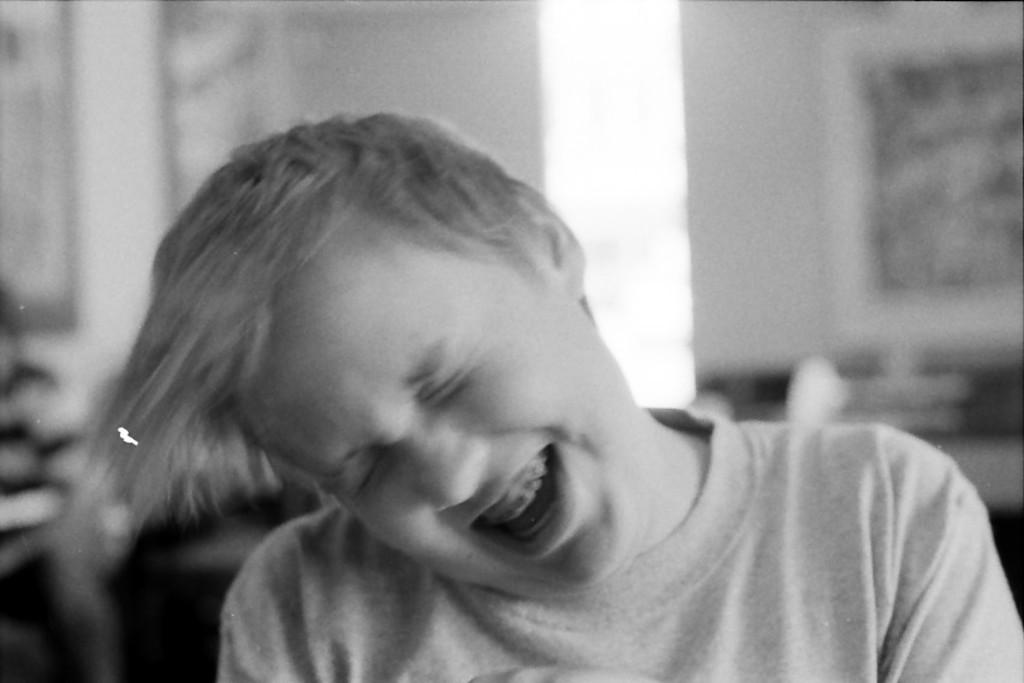What is the color scheme of the image? The image is black and white. Can you describe the main subject in the image? There is a person in the image. What can be observed about the background in the image? The background behind the person is blurred. What type of transport is being used by the person in the image? There is no transport visible in the image, as it is a black and white image of a person with a blurred background. 